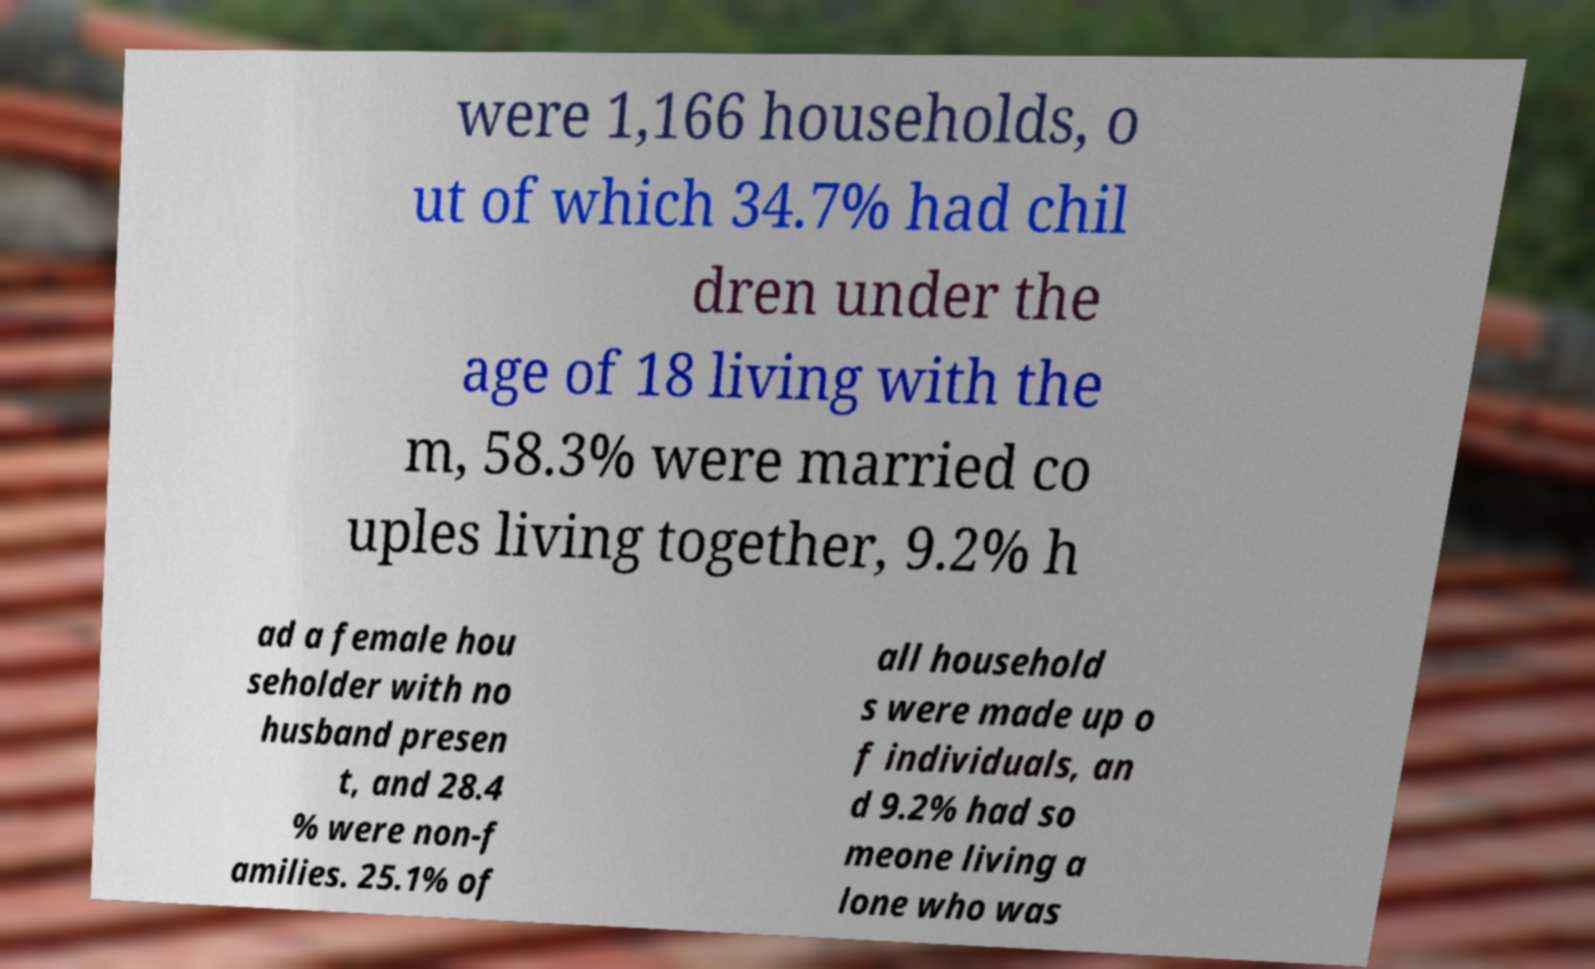Could you extract and type out the text from this image? were 1,166 households, o ut of which 34.7% had chil dren under the age of 18 living with the m, 58.3% were married co uples living together, 9.2% h ad a female hou seholder with no husband presen t, and 28.4 % were non-f amilies. 25.1% of all household s were made up o f individuals, an d 9.2% had so meone living a lone who was 